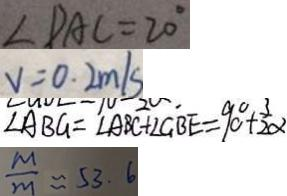Convert formula to latex. <formula><loc_0><loc_0><loc_500><loc_500>\angle D A C = 2 0 ^ { \circ } 
 V = 0 . 2 m / s 
 \angle A B G = \angle A B C + \angle G B E = 9 0 ^ { \circ } + \frac { 3 } { 2 } \alpha 
 \frac { M } { m } \approx 5 3 . 6</formula> 